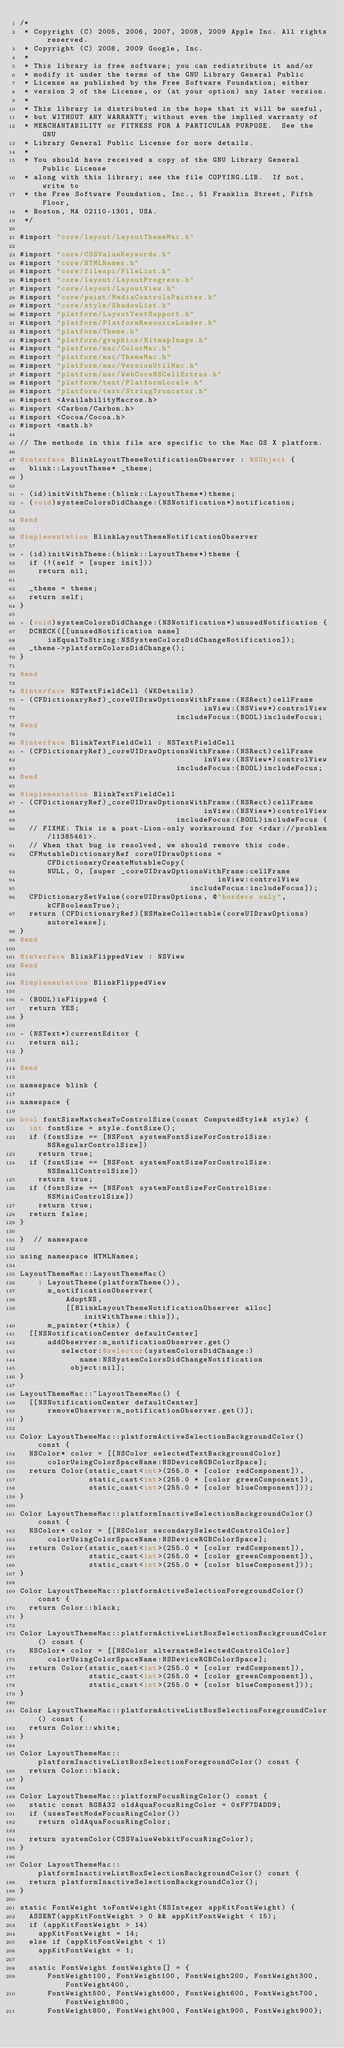<code> <loc_0><loc_0><loc_500><loc_500><_ObjectiveC_>/*
 * Copyright (C) 2005, 2006, 2007, 2008, 2009 Apple Inc. All rights reserved.
 * Copyright (C) 2008, 2009 Google, Inc.
 *
 * This library is free software; you can redistribute it and/or
 * modify it under the terms of the GNU Library General Public
 * License as published by the Free Software Foundation; either
 * version 2 of the License, or (at your option) any later version.
 *
 * This library is distributed in the hope that it will be useful,
 * but WITHOUT ANY WARRANTY; without even the implied warranty of
 * MERCHANTABILITY or FITNESS FOR A PARTICULAR PURPOSE.  See the GNU
 * Library General Public License for more details.
 *
 * You should have received a copy of the GNU Library General Public License
 * along with this library; see the file COPYING.LIB.  If not, write to
 * the Free Software Foundation, Inc., 51 Franklin Street, Fifth Floor,
 * Boston, MA 02110-1301, USA.
 */

#import "core/layout/LayoutThemeMac.h"

#import "core/CSSValueKeywords.h"
#import "core/HTMLNames.h"
#import "core/fileapi/FileList.h"
#import "core/layout/LayoutProgress.h"
#import "core/layout/LayoutView.h"
#import "core/paint/MediaControlsPainter.h"
#import "core/style/ShadowList.h"
#import "platform/LayoutTestSupport.h"
#import "platform/PlatformResourceLoader.h"
#import "platform/Theme.h"
#import "platform/graphics/BitmapImage.h"
#import "platform/mac/ColorMac.h"
#import "platform/mac/ThemeMac.h"
#import "platform/mac/VersionUtilMac.h"
#import "platform/mac/WebCoreNSCellExtras.h"
#import "platform/text/PlatformLocale.h"
#import "platform/text/StringTruncator.h"
#import <AvailabilityMacros.h>
#import <Carbon/Carbon.h>
#import <Cocoa/Cocoa.h>
#import <math.h>

// The methods in this file are specific to the Mac OS X platform.

@interface BlinkLayoutThemeNotificationObserver : NSObject {
  blink::LayoutTheme* _theme;
}

- (id)initWithTheme:(blink::LayoutTheme*)theme;
- (void)systemColorsDidChange:(NSNotification*)notification;

@end

@implementation BlinkLayoutThemeNotificationObserver

- (id)initWithTheme:(blink::LayoutTheme*)theme {
  if (!(self = [super init]))
    return nil;

  _theme = theme;
  return self;
}

- (void)systemColorsDidChange:(NSNotification*)unusedNotification {
  DCHECK([[unusedNotification name]
      isEqualToString:NSSystemColorsDidChangeNotification]);
  _theme->platformColorsDidChange();
}

@end

@interface NSTextFieldCell (WKDetails)
- (CFDictionaryRef)_coreUIDrawOptionsWithFrame:(NSRect)cellFrame
                                        inView:(NSView*)controlView
                                  includeFocus:(BOOL)includeFocus;
@end

@interface BlinkTextFieldCell : NSTextFieldCell
- (CFDictionaryRef)_coreUIDrawOptionsWithFrame:(NSRect)cellFrame
                                        inView:(NSView*)controlView
                                  includeFocus:(BOOL)includeFocus;
@end

@implementation BlinkTextFieldCell
- (CFDictionaryRef)_coreUIDrawOptionsWithFrame:(NSRect)cellFrame
                                        inView:(NSView*)controlView
                                  includeFocus:(BOOL)includeFocus {
  // FIXME: This is a post-Lion-only workaround for <rdar://problem/11385461>.
  // When that bug is resolved, we should remove this code.
  CFMutableDictionaryRef coreUIDrawOptions = CFDictionaryCreateMutableCopy(
      NULL, 0, [super _coreUIDrawOptionsWithFrame:cellFrame
                                           inView:controlView
                                     includeFocus:includeFocus]);
  CFDictionarySetValue(coreUIDrawOptions, @"borders only", kCFBooleanTrue);
  return (CFDictionaryRef)[NSMakeCollectable(coreUIDrawOptions) autorelease];
}
@end

@interface BlinkFlippedView : NSView
@end

@implementation BlinkFlippedView

- (BOOL)isFlipped {
  return YES;
}

- (NSText*)currentEditor {
  return nil;
}

@end

namespace blink {

namespace {

bool fontSizeMatchesToControlSize(const ComputedStyle& style) {
  int fontSize = style.fontSize();
  if (fontSize == [NSFont systemFontSizeForControlSize:NSRegularControlSize])
    return true;
  if (fontSize == [NSFont systemFontSizeForControlSize:NSSmallControlSize])
    return true;
  if (fontSize == [NSFont systemFontSizeForControlSize:NSMiniControlSize])
    return true;
  return false;
}

}  // namespace

using namespace HTMLNames;

LayoutThemeMac::LayoutThemeMac()
    : LayoutTheme(platformTheme()),
      m_notificationObserver(
          AdoptNS,
          [[BlinkLayoutThemeNotificationObserver alloc] initWithTheme:this]),
      m_painter(*this) {
  [[NSNotificationCenter defaultCenter]
      addObserver:m_notificationObserver.get()
         selector:@selector(systemColorsDidChange:)
             name:NSSystemColorsDidChangeNotification
           object:nil];
}

LayoutThemeMac::~LayoutThemeMac() {
  [[NSNotificationCenter defaultCenter]
      removeObserver:m_notificationObserver.get()];
}

Color LayoutThemeMac::platformActiveSelectionBackgroundColor() const {
  NSColor* color = [[NSColor selectedTextBackgroundColor]
      colorUsingColorSpaceName:NSDeviceRGBColorSpace];
  return Color(static_cast<int>(255.0 * [color redComponent]),
               static_cast<int>(255.0 * [color greenComponent]),
               static_cast<int>(255.0 * [color blueComponent]));
}

Color LayoutThemeMac::platformInactiveSelectionBackgroundColor() const {
  NSColor* color = [[NSColor secondarySelectedControlColor]
      colorUsingColorSpaceName:NSDeviceRGBColorSpace];
  return Color(static_cast<int>(255.0 * [color redComponent]),
               static_cast<int>(255.0 * [color greenComponent]),
               static_cast<int>(255.0 * [color blueComponent]));
}

Color LayoutThemeMac::platformActiveSelectionForegroundColor() const {
  return Color::black;
}

Color LayoutThemeMac::platformActiveListBoxSelectionBackgroundColor() const {
  NSColor* color = [[NSColor alternateSelectedControlColor]
      colorUsingColorSpaceName:NSDeviceRGBColorSpace];
  return Color(static_cast<int>(255.0 * [color redComponent]),
               static_cast<int>(255.0 * [color greenComponent]),
               static_cast<int>(255.0 * [color blueComponent]));
}

Color LayoutThemeMac::platformActiveListBoxSelectionForegroundColor() const {
  return Color::white;
}

Color LayoutThemeMac::platformInactiveListBoxSelectionForegroundColor() const {
  return Color::black;
}

Color LayoutThemeMac::platformFocusRingColor() const {
  static const RGBA32 oldAquaFocusRingColor = 0xFF7DADD9;
  if (usesTestModeFocusRingColor())
    return oldAquaFocusRingColor;

  return systemColor(CSSValueWebkitFocusRingColor);
}

Color LayoutThemeMac::platformInactiveListBoxSelectionBackgroundColor() const {
  return platformInactiveSelectionBackgroundColor();
}

static FontWeight toFontWeight(NSInteger appKitFontWeight) {
  ASSERT(appKitFontWeight > 0 && appKitFontWeight < 15);
  if (appKitFontWeight > 14)
    appKitFontWeight = 14;
  else if (appKitFontWeight < 1)
    appKitFontWeight = 1;

  static FontWeight fontWeights[] = {
      FontWeight100, FontWeight100, FontWeight200, FontWeight300, FontWeight400,
      FontWeight500, FontWeight600, FontWeight600, FontWeight700, FontWeight800,
      FontWeight800, FontWeight900, FontWeight900, FontWeight900};</code> 